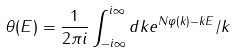<formula> <loc_0><loc_0><loc_500><loc_500>\theta ( E ) = \frac { 1 } { 2 \pi i } \int _ { - i \infty } ^ { i \infty } d k e ^ { N \varphi ( k ) - k E } / k</formula> 